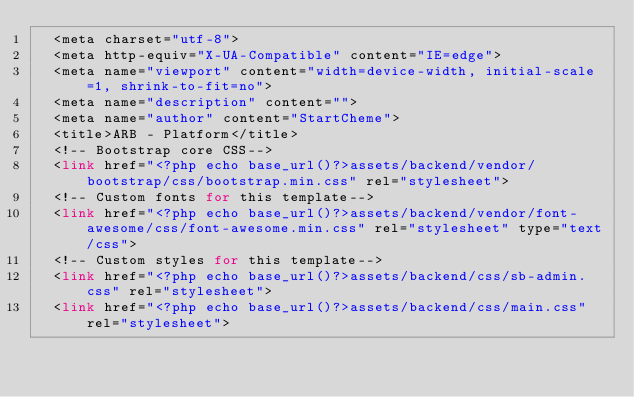Convert code to text. <code><loc_0><loc_0><loc_500><loc_500><_PHP_>  <meta charset="utf-8">
  <meta http-equiv="X-UA-Compatible" content="IE=edge">
  <meta name="viewport" content="width=device-width, initial-scale=1, shrink-to-fit=no">
  <meta name="description" content="">
  <meta name="author" content="StartCheme">
  <title>ARB - Platform</title>
  <!-- Bootstrap core CSS-->
  <link href="<?php echo base_url()?>assets/backend/vendor/bootstrap/css/bootstrap.min.css" rel="stylesheet">
  <!-- Custom fonts for this template-->
  <link href="<?php echo base_url()?>assets/backend/vendor/font-awesome/css/font-awesome.min.css" rel="stylesheet" type="text/css">
  <!-- Custom styles for this template-->
  <link href="<?php echo base_url()?>assets/backend/css/sb-admin.css" rel="stylesheet">
  <link href="<?php echo base_url()?>assets/backend/css/main.css" rel="stylesheet"></code> 